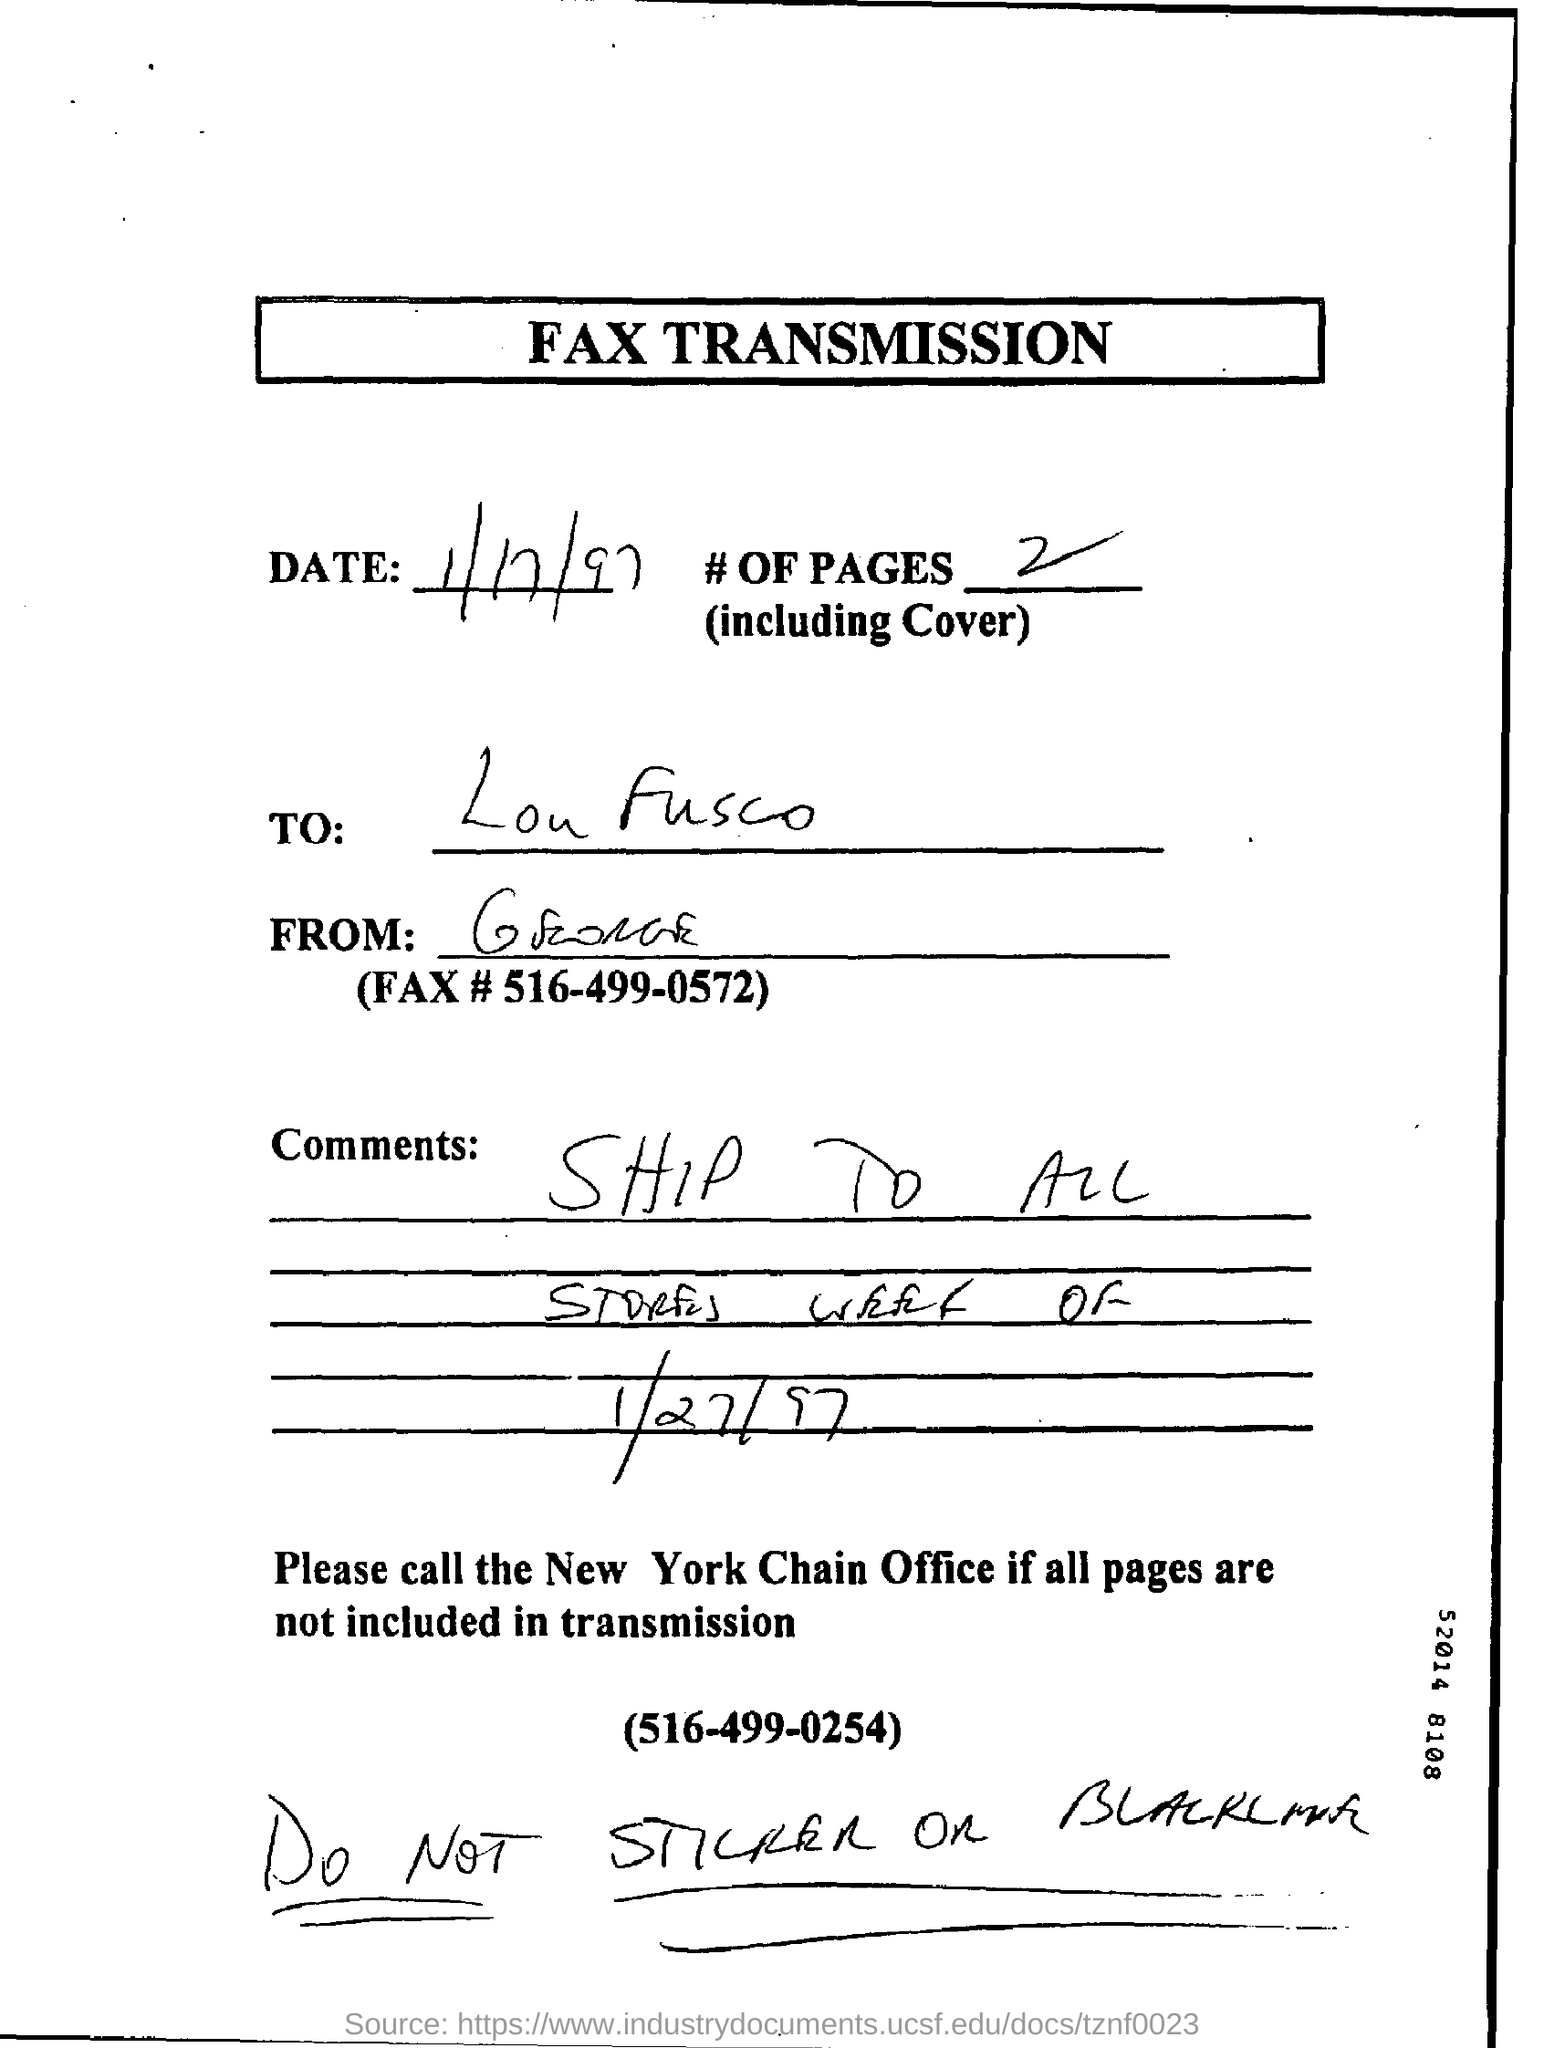Date of fax transmission?
Keep it short and to the point. 1/17/97. How many pages are including cover?
Provide a short and direct response. 2. 